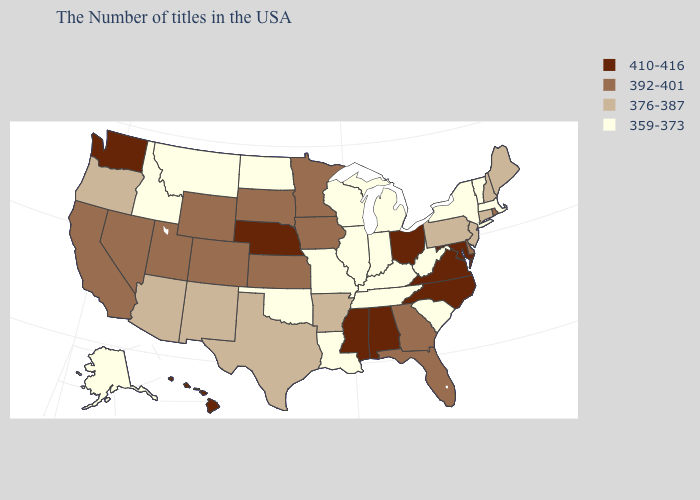What is the lowest value in the MidWest?
Quick response, please. 359-373. Name the states that have a value in the range 359-373?
Short answer required. Massachusetts, Vermont, New York, South Carolina, West Virginia, Michigan, Kentucky, Indiana, Tennessee, Wisconsin, Illinois, Louisiana, Missouri, Oklahoma, North Dakota, Montana, Idaho, Alaska. Which states hav the highest value in the South?
Be succinct. Maryland, Virginia, North Carolina, Alabama, Mississippi. Name the states that have a value in the range 376-387?
Quick response, please. Maine, New Hampshire, Connecticut, New Jersey, Pennsylvania, Arkansas, Texas, New Mexico, Arizona, Oregon. Among the states that border Nevada , which have the lowest value?
Concise answer only. Idaho. Among the states that border New York , which have the highest value?
Short answer required. Connecticut, New Jersey, Pennsylvania. What is the value of Utah?
Be succinct. 392-401. What is the lowest value in states that border Idaho?
Short answer required. 359-373. What is the value of Hawaii?
Write a very short answer. 410-416. Name the states that have a value in the range 376-387?
Short answer required. Maine, New Hampshire, Connecticut, New Jersey, Pennsylvania, Arkansas, Texas, New Mexico, Arizona, Oregon. What is the lowest value in states that border Indiana?
Write a very short answer. 359-373. Which states have the lowest value in the West?
Quick response, please. Montana, Idaho, Alaska. Name the states that have a value in the range 392-401?
Answer briefly. Rhode Island, Delaware, Florida, Georgia, Minnesota, Iowa, Kansas, South Dakota, Wyoming, Colorado, Utah, Nevada, California. What is the highest value in the USA?
Short answer required. 410-416. Is the legend a continuous bar?
Be succinct. No. 